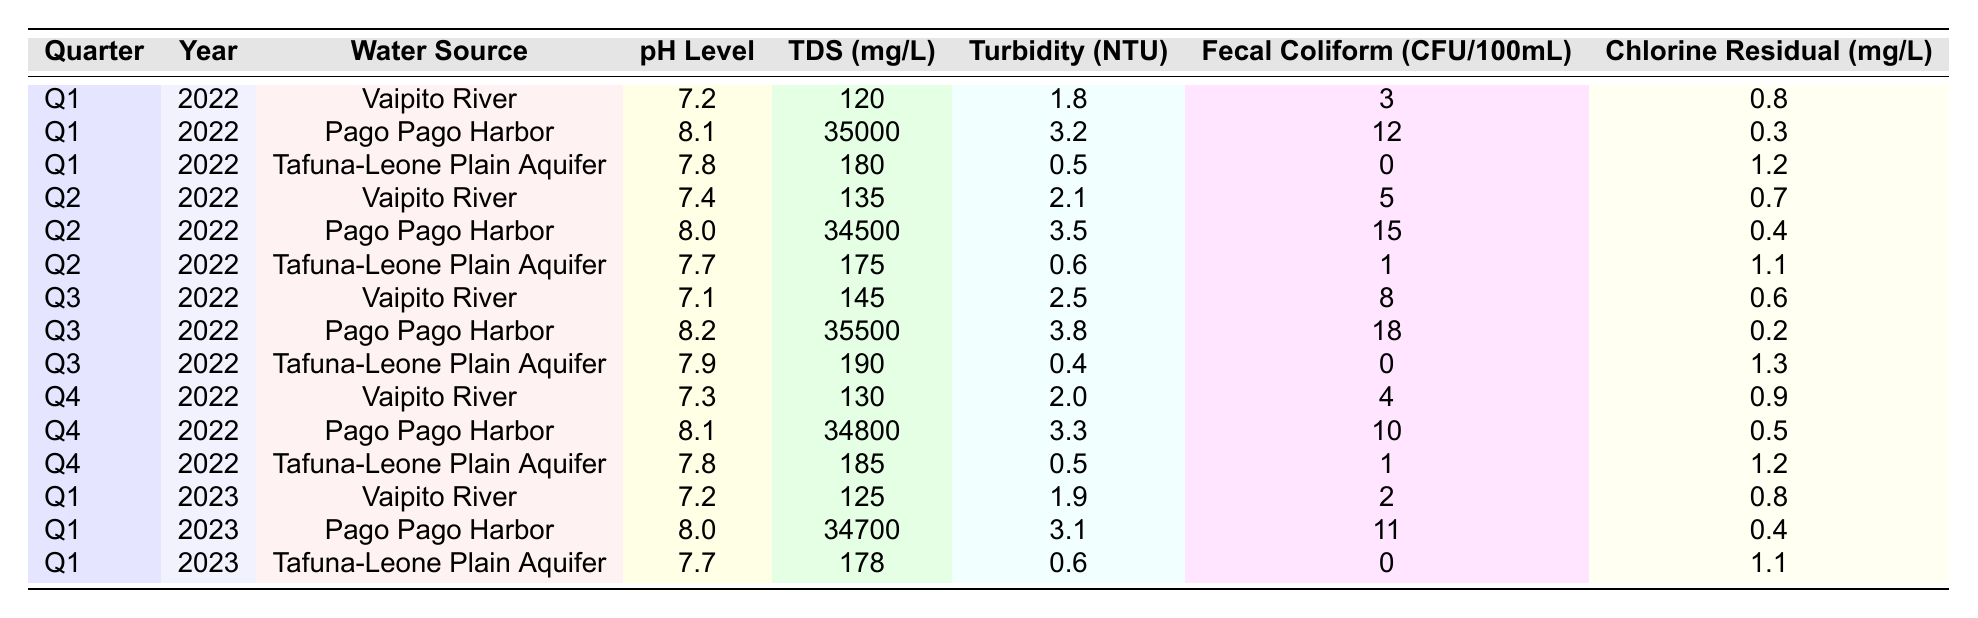What is the pH level of the Tafuna-Leone Plain Aquifer in Q1 2023? The table shows that in Q1 2023, the pH level of the Tafuna-Leone Plain Aquifer is listed as 7.7.
Answer: 7.7 What is the Total Dissolved Solids (TDS) level for Pago Pago Harbor in Q3 2022? The table states that in Q3 2022, the TDS level for Pago Pago Harbor is 35,500 mg/L.
Answer: 35,500 Which water source had the highest turbidity in 2022? By examining the turbidity values for each quarter in 2022, Pago Pago Harbor in Q3 2022 had the highest turbidity at 3.8 NTU.
Answer: Pago Pago Harbor What is the average fecal coliform count for Vaipito River over the four quarters in 2022? The fecal coliform counts for Vaipito River in Q1, Q2, Q3, and Q4 of 2022 are 3, 5, 8, and 4, respectively. The average is calculated as (3 + 5 + 8 + 4) / 4 = 20 / 4 = 5.
Answer: 5 Did the chlorine residual level of Tafuna-Leone Plain Aquifer increase from Q2 2022 to Q4 2022? In Q2 2022, the chlorine residual level was 1.1 mg/L, while in Q4 2022 it was 1.2 mg/L; thus, it did increase.
Answer: Yes Which quarter had the lowest pH level for the Vaipito River in 2022? The pH levels for the Vaipito River in 2022 were 7.2 (Q1), 7.4 (Q2), 7.1 (Q3), and 7.3 (Q4). The lowest pH level recorded is 7.1 in Q3.
Answer: Q3 2022 What is the change in turbidity for Tafuna-Leone Plain Aquifer from Q1 2022 to Q1 2023? The turbidity for Tafuna-Leone Plain Aquifer is 0.5 NTU in Q1 2022 and 0.6 NTU in Q1 2023. The change is 0.6 - 0.5 = 0.1 NTU.
Answer: 0.1 NTU Is there any quarter in 2022 when Pago Pago Harbor reported a fecal coliform count higher than 15? The fecal coliform counts for Pago Pago Harbor in 2022 are 12 (Q1), 15 (Q2), 18 (Q3), and 10 (Q4). Since Q3 has the highest at 18, the statement is true.
Answer: Yes Which water source consistently had the lowest Total Dissolved Solids (TDS) levels across all quarters in 2022? Reviewing the TDS levels, the Tafuna-Leone Plain Aquifer recorded 180 (Q1), 175 (Q2), 190 (Q3), and 185 (Q4), which are all lower than Pago Pago Harbor. Thus, it had the lowest TDS.
Answer: Tafuna-Leone Plain Aquifer What is the year with the highest recorded chlorine residual level for Vaipito River? The chlorine residual levels for Vaipito River are available for 2022 and 2023; they are 0.8 (Q1), 0.7 (Q2), 0.6 (Q3), 0.9 (Q4) for 2022, and 0.8 (Q1) for 2023. The highest is 0.9 mg/L in Q4 2022.
Answer: 2022 